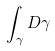Convert formula to latex. <formula><loc_0><loc_0><loc_500><loc_500>\int _ { \gamma } D \gamma</formula> 